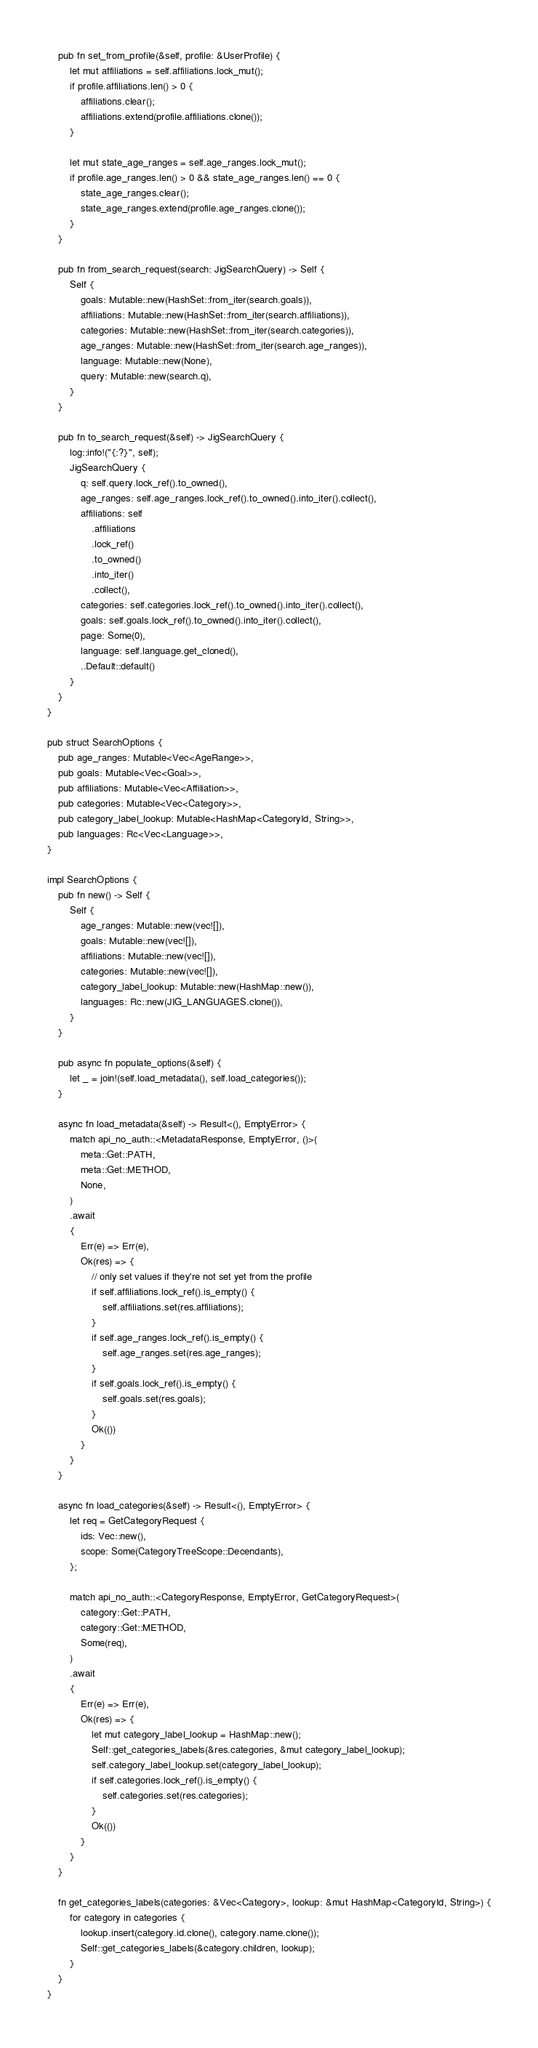Convert code to text. <code><loc_0><loc_0><loc_500><loc_500><_Rust_>
    pub fn set_from_profile(&self, profile: &UserProfile) {
        let mut affiliations = self.affiliations.lock_mut();
        if profile.affiliations.len() > 0 {
            affiliations.clear();
            affiliations.extend(profile.affiliations.clone());
        }

        let mut state_age_ranges = self.age_ranges.lock_mut();
        if profile.age_ranges.len() > 0 && state_age_ranges.len() == 0 {
            state_age_ranges.clear();
            state_age_ranges.extend(profile.age_ranges.clone());
        }
    }

    pub fn from_search_request(search: JigSearchQuery) -> Self {
        Self {
            goals: Mutable::new(HashSet::from_iter(search.goals)),
            affiliations: Mutable::new(HashSet::from_iter(search.affiliations)),
            categories: Mutable::new(HashSet::from_iter(search.categories)),
            age_ranges: Mutable::new(HashSet::from_iter(search.age_ranges)),
            language: Mutable::new(None),
            query: Mutable::new(search.q),
        }
    }

    pub fn to_search_request(&self) -> JigSearchQuery {
        log::info!("{:?}", self);
        JigSearchQuery {
            q: self.query.lock_ref().to_owned(),
            age_ranges: self.age_ranges.lock_ref().to_owned().into_iter().collect(),
            affiliations: self
                .affiliations
                .lock_ref()
                .to_owned()
                .into_iter()
                .collect(),
            categories: self.categories.lock_ref().to_owned().into_iter().collect(),
            goals: self.goals.lock_ref().to_owned().into_iter().collect(),
            page: Some(0),
            language: self.language.get_cloned(),
            ..Default::default()
        }
    }
}

pub struct SearchOptions {
    pub age_ranges: Mutable<Vec<AgeRange>>,
    pub goals: Mutable<Vec<Goal>>,
    pub affiliations: Mutable<Vec<Affiliation>>,
    pub categories: Mutable<Vec<Category>>,
    pub category_label_lookup: Mutable<HashMap<CategoryId, String>>,
    pub languages: Rc<Vec<Language>>,
}

impl SearchOptions {
    pub fn new() -> Self {
        Self {
            age_ranges: Mutable::new(vec![]),
            goals: Mutable::new(vec![]),
            affiliations: Mutable::new(vec![]),
            categories: Mutable::new(vec![]),
            category_label_lookup: Mutable::new(HashMap::new()),
            languages: Rc::new(JIG_LANGUAGES.clone()),
        }
    }

    pub async fn populate_options(&self) {
        let _ = join!(self.load_metadata(), self.load_categories());
    }

    async fn load_metadata(&self) -> Result<(), EmptyError> {
        match api_no_auth::<MetadataResponse, EmptyError, ()>(
            meta::Get::PATH,
            meta::Get::METHOD,
            None,
        )
        .await
        {
            Err(e) => Err(e),
            Ok(res) => {
                // only set values if they're not set yet from the profile
                if self.affiliations.lock_ref().is_empty() {
                    self.affiliations.set(res.affiliations);
                }
                if self.age_ranges.lock_ref().is_empty() {
                    self.age_ranges.set(res.age_ranges);
                }
                if self.goals.lock_ref().is_empty() {
                    self.goals.set(res.goals);
                }
                Ok(())
            }
        }
    }

    async fn load_categories(&self) -> Result<(), EmptyError> {
        let req = GetCategoryRequest {
            ids: Vec::new(),
            scope: Some(CategoryTreeScope::Decendants),
        };

        match api_no_auth::<CategoryResponse, EmptyError, GetCategoryRequest>(
            category::Get::PATH,
            category::Get::METHOD,
            Some(req),
        )
        .await
        {
            Err(e) => Err(e),
            Ok(res) => {
                let mut category_label_lookup = HashMap::new();
                Self::get_categories_labels(&res.categories, &mut category_label_lookup);
                self.category_label_lookup.set(category_label_lookup);
                if self.categories.lock_ref().is_empty() {
                    self.categories.set(res.categories);
                }
                Ok(())
            }
        }
    }

    fn get_categories_labels(categories: &Vec<Category>, lookup: &mut HashMap<CategoryId, String>) {
        for category in categories {
            lookup.insert(category.id.clone(), category.name.clone());
            Self::get_categories_labels(&category.children, lookup);
        }
    }
}
</code> 